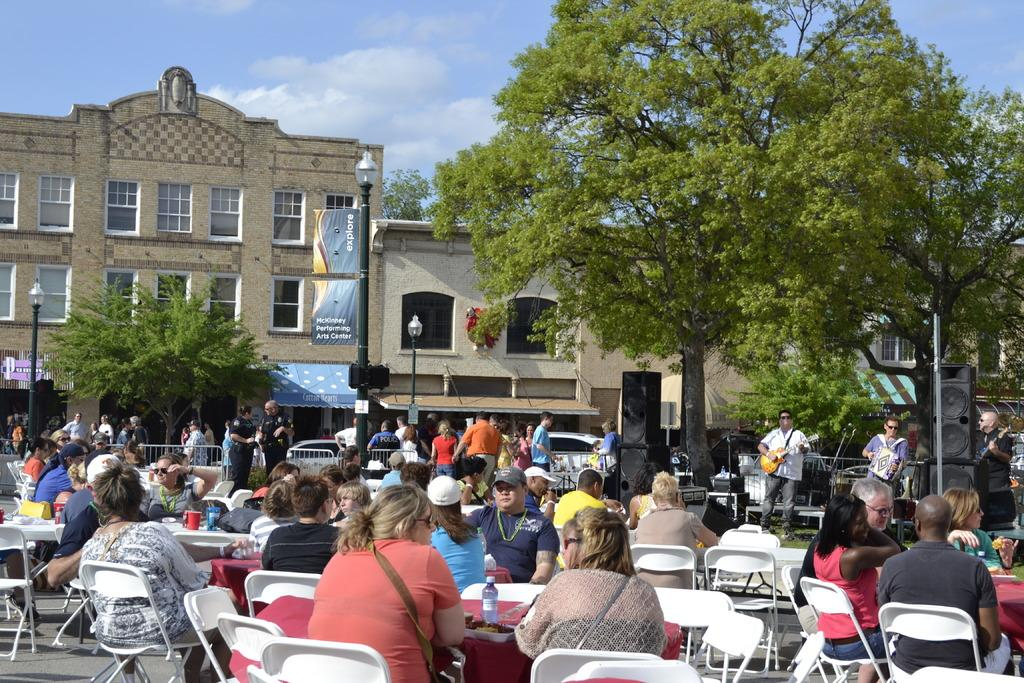How many people are in the image? There is a group of people in the image, but the exact number cannot be determined from the provided facts. What are the people in the image doing? Some people are sitting, and some people are standing. What can be seen in the background of the image? There are trees, sky, and a banner visible in the background of the image. What color is the parcel being held by one of the people in the image? There is no parcel present in the image, so it is not possible to determine its color. What name is written on the banner in the image? The provided facts do not mention any names or text on the banner, so it is not possible to determine what name, if any, is written on it. 